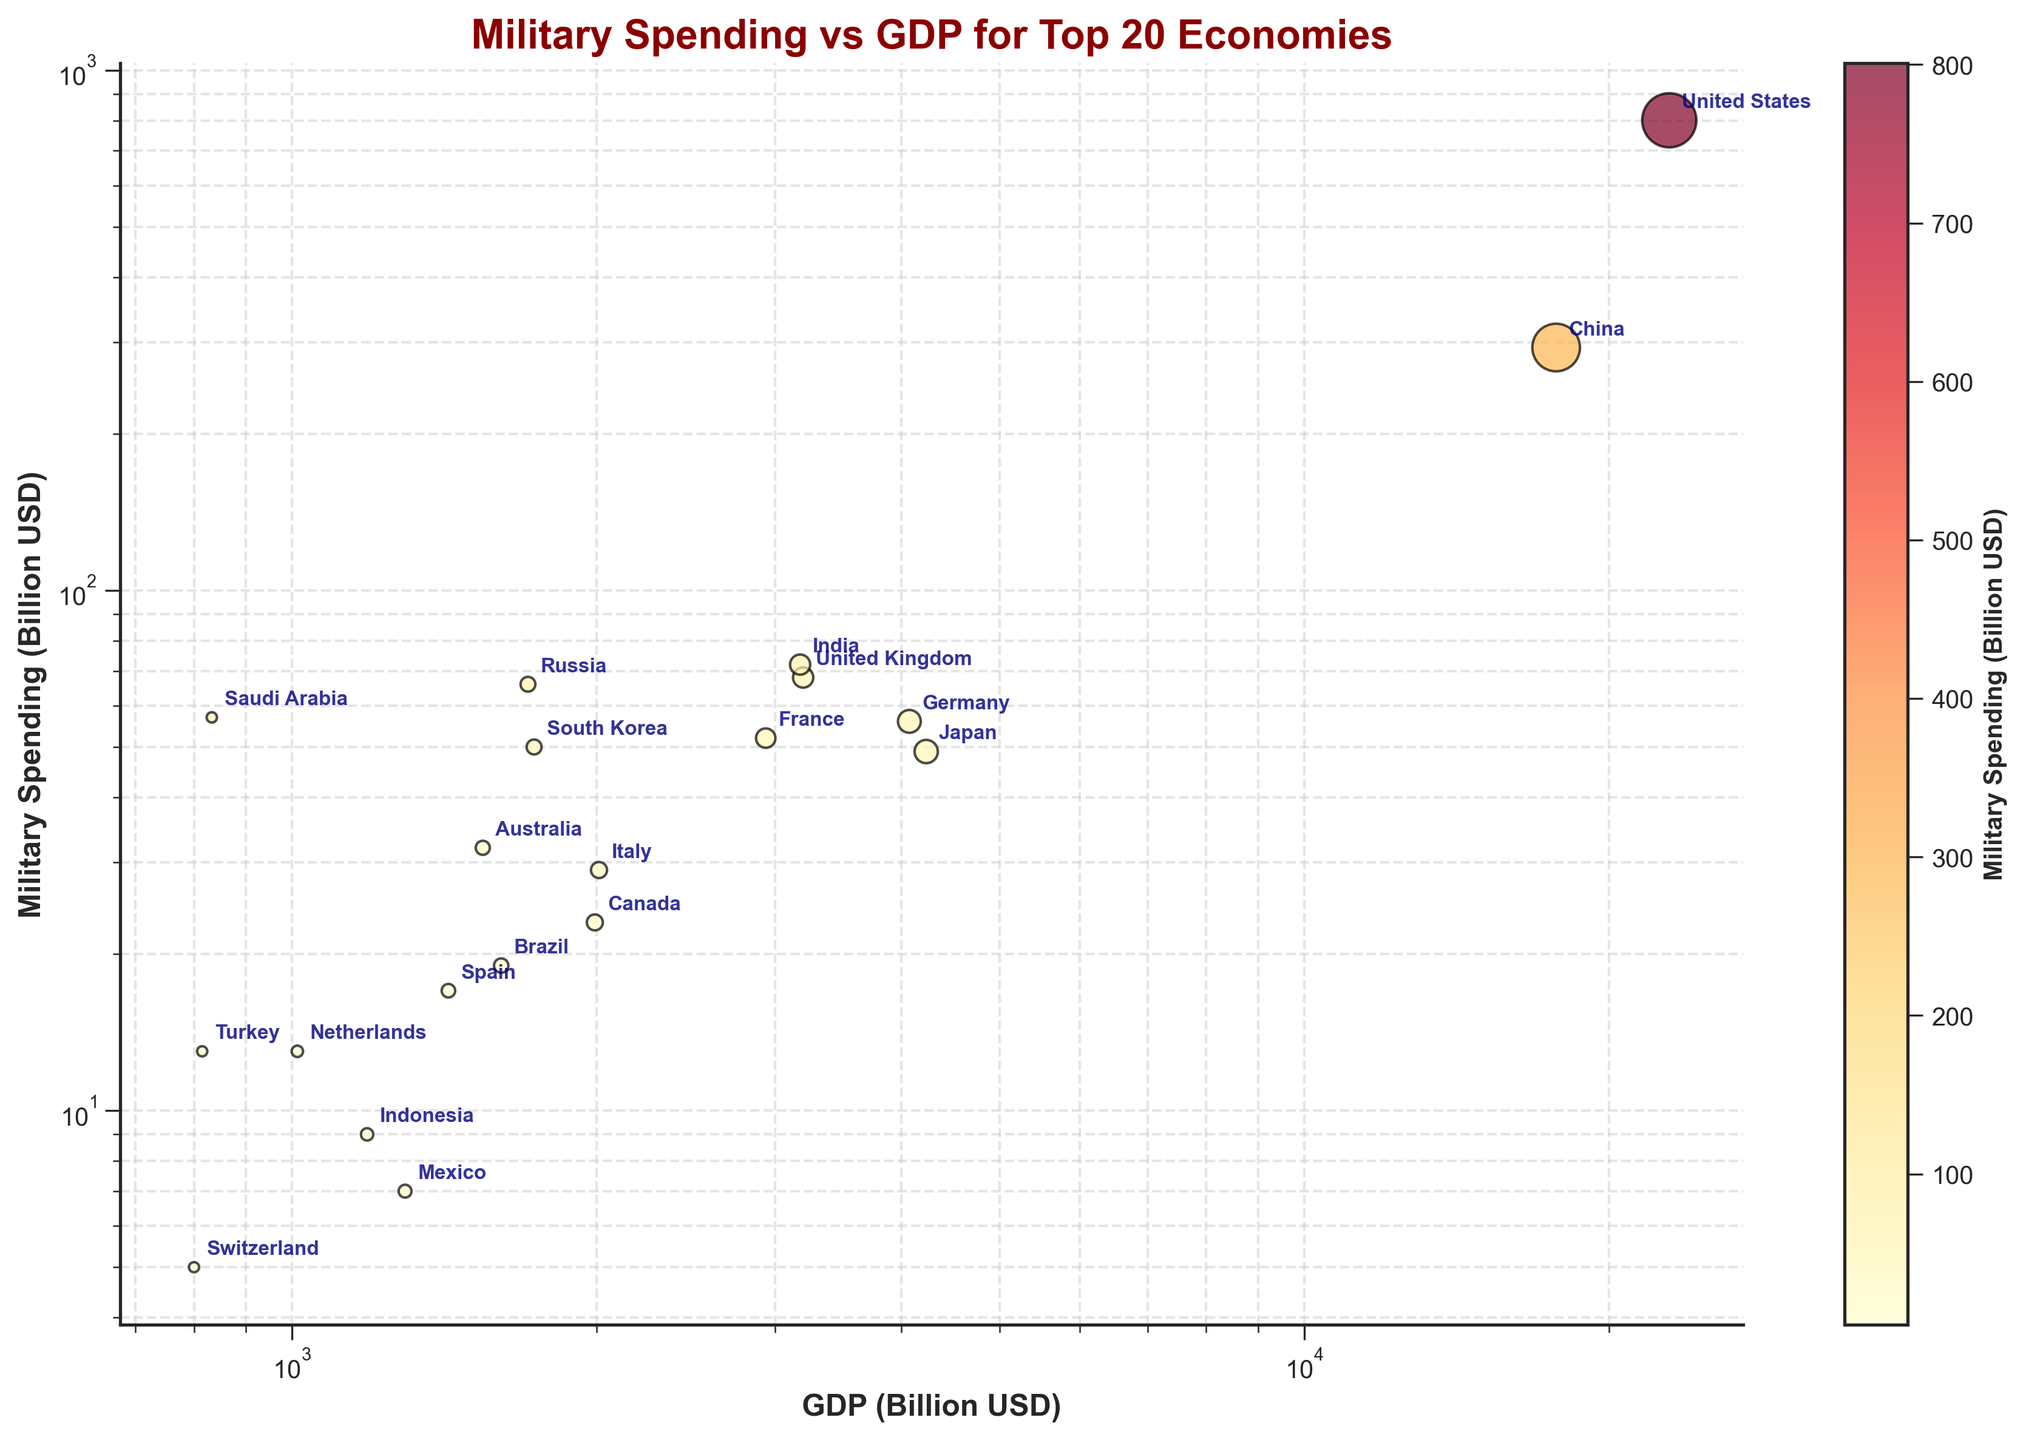How many countries have GDP values displayed on the plot? The scatter plot has 20 data points, each representing one of the top 20 economies by GDP.
Answer: 20 What is the title of the scatter plot? The title of the plot is displayed at the top in a prominent font.
Answer: Military Spending vs GDP for Top 20 Economies Which country has the highest military spending? By observing the y-axis and the data points, the country with the highest military spending can be identified.
Answer: United States Which two countries have similar military spending but different GDPs? By looking at the annotated countries, one can find pairs with close military spending values yet distinct GDP values. For example, France and the United Kingdom, both spend around 52-68 billion USD, but UK's GDP is approximately 3198 billion USD compared to France's 2937 billion USD.
Answer: France and United Kingdom What is the color code used for lower military spending countries? The scatter plot uses a color gradient ranging from yellow for lower spending to red for higher spending values.
Answer: Yellow to light orange Between Germany and Russia, which country spends more on the military? By comparing the y-coordinate values for Germany and Russia's data points, it's clear which has a higher military expenditure.
Answer: Russia Estimate the approximate military spending for countries with a GDP below 1000 billion USD. Observing the data points towards the left end of the x-axis, we can approximate these values. For example, Saudi Arabia spends 57 billion USD, while others like Mexico and Switzerland spend below 10 billion USD.
Answer: Mostly below 10 billion USD, with Saudi Arabia around 57 billion USD Which country appears closest to Japan in terms of military spending? Looking at the positions on the y-axis, the country nearest Japan in terms of military spending can be identified.
Answer: South Korea How are the axes scaled in the scatter plot? The x-axis and y-axis use logarithmic scales, as noted by the 'log' labels on both axes.
Answer: Logarithmic Identify two countries where one of them has a higher GDP but lower military spending compared to the other. Comparing countries, such as China and India, where China has a higher GDP but lower military spending (17734 billion USD GDP and 293 billion USD spending) compared to India (3176 billion USD GDP and 72 billion USD spending).
Answer: China and India 